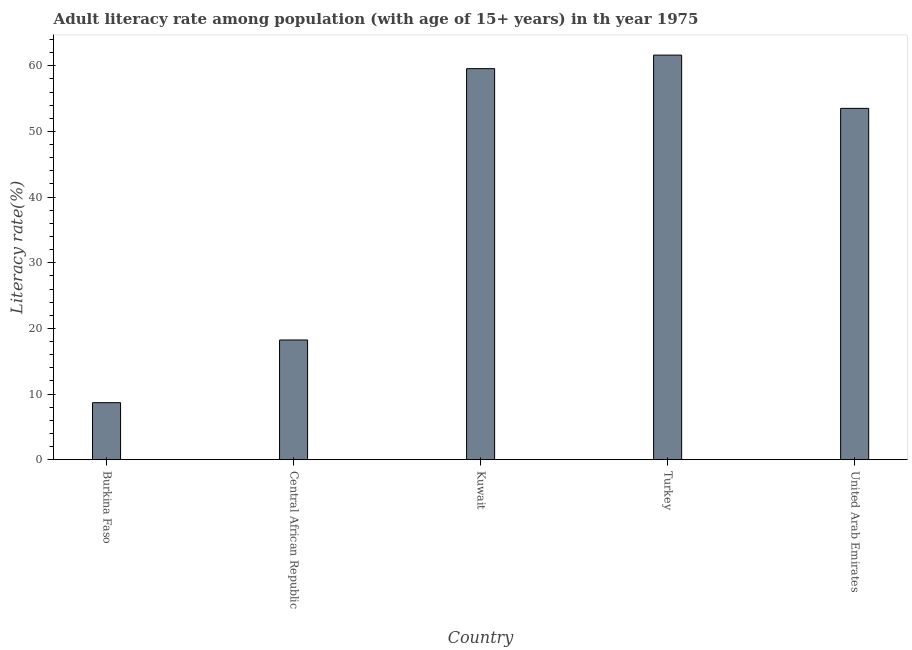What is the title of the graph?
Keep it short and to the point. Adult literacy rate among population (with age of 15+ years) in th year 1975. What is the label or title of the X-axis?
Make the answer very short. Country. What is the label or title of the Y-axis?
Provide a short and direct response. Literacy rate(%). What is the adult literacy rate in Central African Republic?
Your answer should be very brief. 18.24. Across all countries, what is the maximum adult literacy rate?
Your answer should be very brief. 61.63. Across all countries, what is the minimum adult literacy rate?
Provide a succinct answer. 8.69. In which country was the adult literacy rate minimum?
Your response must be concise. Burkina Faso. What is the sum of the adult literacy rate?
Offer a very short reply. 201.63. What is the difference between the adult literacy rate in Kuwait and United Arab Emirates?
Make the answer very short. 6.05. What is the average adult literacy rate per country?
Give a very brief answer. 40.33. What is the median adult literacy rate?
Your answer should be very brief. 53.51. What is the ratio of the adult literacy rate in Burkina Faso to that in Turkey?
Your answer should be compact. 0.14. Is the difference between the adult literacy rate in Kuwait and United Arab Emirates greater than the difference between any two countries?
Provide a succinct answer. No. What is the difference between the highest and the second highest adult literacy rate?
Give a very brief answer. 2.06. Is the sum of the adult literacy rate in Kuwait and Turkey greater than the maximum adult literacy rate across all countries?
Your response must be concise. Yes. What is the difference between the highest and the lowest adult literacy rate?
Provide a succinct answer. 52.94. In how many countries, is the adult literacy rate greater than the average adult literacy rate taken over all countries?
Make the answer very short. 3. How many bars are there?
Offer a terse response. 5. Are all the bars in the graph horizontal?
Provide a succinct answer. No. What is the Literacy rate(%) of Burkina Faso?
Provide a succinct answer. 8.69. What is the Literacy rate(%) of Central African Republic?
Offer a very short reply. 18.24. What is the Literacy rate(%) of Kuwait?
Your response must be concise. 59.56. What is the Literacy rate(%) in Turkey?
Make the answer very short. 61.63. What is the Literacy rate(%) of United Arab Emirates?
Your response must be concise. 53.51. What is the difference between the Literacy rate(%) in Burkina Faso and Central African Republic?
Your answer should be very brief. -9.55. What is the difference between the Literacy rate(%) in Burkina Faso and Kuwait?
Your answer should be very brief. -50.88. What is the difference between the Literacy rate(%) in Burkina Faso and Turkey?
Provide a succinct answer. -52.94. What is the difference between the Literacy rate(%) in Burkina Faso and United Arab Emirates?
Ensure brevity in your answer.  -44.83. What is the difference between the Literacy rate(%) in Central African Republic and Kuwait?
Keep it short and to the point. -41.33. What is the difference between the Literacy rate(%) in Central African Republic and Turkey?
Your answer should be compact. -43.39. What is the difference between the Literacy rate(%) in Central African Republic and United Arab Emirates?
Offer a very short reply. -35.28. What is the difference between the Literacy rate(%) in Kuwait and Turkey?
Provide a succinct answer. -2.06. What is the difference between the Literacy rate(%) in Kuwait and United Arab Emirates?
Offer a terse response. 6.05. What is the difference between the Literacy rate(%) in Turkey and United Arab Emirates?
Offer a very short reply. 8.11. What is the ratio of the Literacy rate(%) in Burkina Faso to that in Central African Republic?
Your answer should be compact. 0.48. What is the ratio of the Literacy rate(%) in Burkina Faso to that in Kuwait?
Make the answer very short. 0.15. What is the ratio of the Literacy rate(%) in Burkina Faso to that in Turkey?
Ensure brevity in your answer.  0.14. What is the ratio of the Literacy rate(%) in Burkina Faso to that in United Arab Emirates?
Give a very brief answer. 0.16. What is the ratio of the Literacy rate(%) in Central African Republic to that in Kuwait?
Your answer should be compact. 0.31. What is the ratio of the Literacy rate(%) in Central African Republic to that in Turkey?
Make the answer very short. 0.3. What is the ratio of the Literacy rate(%) in Central African Republic to that in United Arab Emirates?
Offer a very short reply. 0.34. What is the ratio of the Literacy rate(%) in Kuwait to that in United Arab Emirates?
Provide a short and direct response. 1.11. What is the ratio of the Literacy rate(%) in Turkey to that in United Arab Emirates?
Keep it short and to the point. 1.15. 